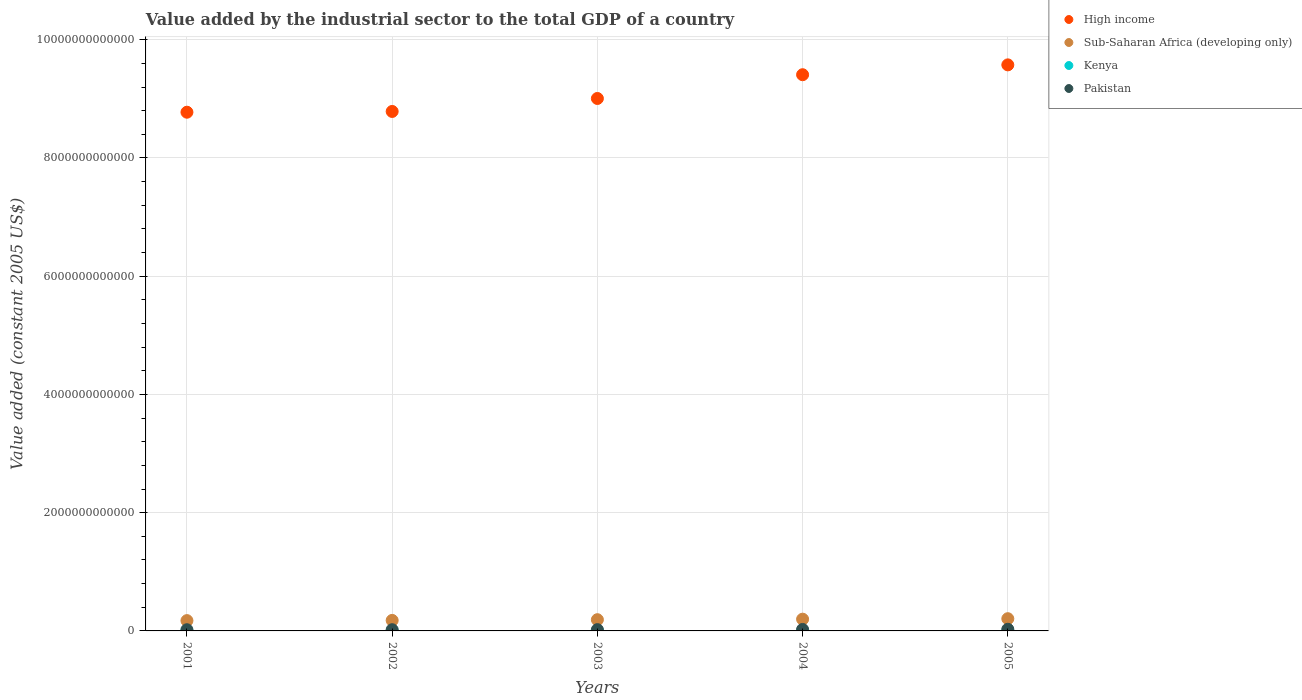How many different coloured dotlines are there?
Keep it short and to the point. 4. Is the number of dotlines equal to the number of legend labels?
Your answer should be very brief. Yes. What is the value added by the industrial sector in Pakistan in 2002?
Provide a succinct answer. 2.06e+1. Across all years, what is the maximum value added by the industrial sector in Kenya?
Offer a very short reply. 3.19e+09. Across all years, what is the minimum value added by the industrial sector in Pakistan?
Give a very brief answer. 2.00e+1. In which year was the value added by the industrial sector in Sub-Saharan Africa (developing only) maximum?
Offer a very short reply. 2005. In which year was the value added by the industrial sector in Kenya minimum?
Give a very brief answer. 2001. What is the total value added by the industrial sector in Sub-Saharan Africa (developing only) in the graph?
Provide a succinct answer. 9.48e+11. What is the difference between the value added by the industrial sector in Sub-Saharan Africa (developing only) in 2001 and that in 2005?
Offer a terse response. -3.26e+1. What is the difference between the value added by the industrial sector in High income in 2001 and the value added by the industrial sector in Pakistan in 2005?
Provide a short and direct response. 8.75e+12. What is the average value added by the industrial sector in High income per year?
Make the answer very short. 9.11e+12. In the year 2004, what is the difference between the value added by the industrial sector in Sub-Saharan Africa (developing only) and value added by the industrial sector in High income?
Provide a succinct answer. -9.21e+12. What is the ratio of the value added by the industrial sector in Kenya in 2002 to that in 2003?
Make the answer very short. 0.94. Is the value added by the industrial sector in High income in 2002 less than that in 2003?
Your answer should be very brief. Yes. Is the difference between the value added by the industrial sector in Sub-Saharan Africa (developing only) in 2002 and 2005 greater than the difference between the value added by the industrial sector in High income in 2002 and 2005?
Keep it short and to the point. Yes. What is the difference between the highest and the second highest value added by the industrial sector in Sub-Saharan Africa (developing only)?
Give a very brief answer. 8.32e+09. What is the difference between the highest and the lowest value added by the industrial sector in Kenya?
Ensure brevity in your answer.  4.86e+08. In how many years, is the value added by the industrial sector in Kenya greater than the average value added by the industrial sector in Kenya taken over all years?
Ensure brevity in your answer.  3. Is it the case that in every year, the sum of the value added by the industrial sector in Sub-Saharan Africa (developing only) and value added by the industrial sector in Pakistan  is greater than the sum of value added by the industrial sector in Kenya and value added by the industrial sector in High income?
Provide a short and direct response. No. Does the value added by the industrial sector in High income monotonically increase over the years?
Provide a succinct answer. Yes. Is the value added by the industrial sector in Pakistan strictly less than the value added by the industrial sector in High income over the years?
Your response must be concise. Yes. How many dotlines are there?
Provide a short and direct response. 4. What is the difference between two consecutive major ticks on the Y-axis?
Keep it short and to the point. 2.00e+12. Are the values on the major ticks of Y-axis written in scientific E-notation?
Your answer should be compact. No. Does the graph contain any zero values?
Keep it short and to the point. No. Does the graph contain grids?
Keep it short and to the point. Yes. Where does the legend appear in the graph?
Your answer should be very brief. Top right. How many legend labels are there?
Ensure brevity in your answer.  4. What is the title of the graph?
Your answer should be compact. Value added by the industrial sector to the total GDP of a country. Does "Macao" appear as one of the legend labels in the graph?
Ensure brevity in your answer.  No. What is the label or title of the X-axis?
Your answer should be very brief. Years. What is the label or title of the Y-axis?
Ensure brevity in your answer.  Value added (constant 2005 US$). What is the Value added (constant 2005 US$) of High income in 2001?
Make the answer very short. 8.77e+12. What is the Value added (constant 2005 US$) of Sub-Saharan Africa (developing only) in 2001?
Your answer should be compact. 1.74e+11. What is the Value added (constant 2005 US$) of Kenya in 2001?
Offer a terse response. 2.70e+09. What is the Value added (constant 2005 US$) in Pakistan in 2001?
Provide a short and direct response. 2.00e+1. What is the Value added (constant 2005 US$) in High income in 2002?
Your answer should be very brief. 8.79e+12. What is the Value added (constant 2005 US$) of Sub-Saharan Africa (developing only) in 2002?
Provide a succinct answer. 1.78e+11. What is the Value added (constant 2005 US$) in Kenya in 2002?
Offer a terse response. 2.77e+09. What is the Value added (constant 2005 US$) in Pakistan in 2002?
Give a very brief answer. 2.06e+1. What is the Value added (constant 2005 US$) of High income in 2003?
Provide a short and direct response. 9.01e+12. What is the Value added (constant 2005 US$) in Sub-Saharan Africa (developing only) in 2003?
Provide a succinct answer. 1.90e+11. What is the Value added (constant 2005 US$) of Kenya in 2003?
Offer a very short reply. 2.93e+09. What is the Value added (constant 2005 US$) of Pakistan in 2003?
Offer a terse response. 2.14e+1. What is the Value added (constant 2005 US$) of High income in 2004?
Offer a terse response. 9.41e+12. What is the Value added (constant 2005 US$) in Sub-Saharan Africa (developing only) in 2004?
Ensure brevity in your answer.  1.99e+11. What is the Value added (constant 2005 US$) in Kenya in 2004?
Offer a terse response. 3.05e+09. What is the Value added (constant 2005 US$) of Pakistan in 2004?
Make the answer very short. 2.49e+1. What is the Value added (constant 2005 US$) of High income in 2005?
Keep it short and to the point. 9.57e+12. What is the Value added (constant 2005 US$) in Sub-Saharan Africa (developing only) in 2005?
Your response must be concise. 2.07e+11. What is the Value added (constant 2005 US$) in Kenya in 2005?
Your answer should be compact. 3.19e+09. What is the Value added (constant 2005 US$) in Pakistan in 2005?
Offer a terse response. 2.80e+1. Across all years, what is the maximum Value added (constant 2005 US$) of High income?
Make the answer very short. 9.57e+12. Across all years, what is the maximum Value added (constant 2005 US$) in Sub-Saharan Africa (developing only)?
Your response must be concise. 2.07e+11. Across all years, what is the maximum Value added (constant 2005 US$) of Kenya?
Make the answer very short. 3.19e+09. Across all years, what is the maximum Value added (constant 2005 US$) in Pakistan?
Offer a terse response. 2.80e+1. Across all years, what is the minimum Value added (constant 2005 US$) in High income?
Your response must be concise. 8.77e+12. Across all years, what is the minimum Value added (constant 2005 US$) in Sub-Saharan Africa (developing only)?
Keep it short and to the point. 1.74e+11. Across all years, what is the minimum Value added (constant 2005 US$) of Kenya?
Provide a short and direct response. 2.70e+09. Across all years, what is the minimum Value added (constant 2005 US$) of Pakistan?
Provide a short and direct response. 2.00e+1. What is the total Value added (constant 2005 US$) in High income in the graph?
Keep it short and to the point. 4.55e+13. What is the total Value added (constant 2005 US$) in Sub-Saharan Africa (developing only) in the graph?
Provide a short and direct response. 9.48e+11. What is the total Value added (constant 2005 US$) in Kenya in the graph?
Ensure brevity in your answer.  1.46e+1. What is the total Value added (constant 2005 US$) of Pakistan in the graph?
Provide a succinct answer. 1.15e+11. What is the difference between the Value added (constant 2005 US$) in High income in 2001 and that in 2002?
Give a very brief answer. -1.29e+1. What is the difference between the Value added (constant 2005 US$) of Sub-Saharan Africa (developing only) in 2001 and that in 2002?
Offer a very short reply. -3.59e+09. What is the difference between the Value added (constant 2005 US$) in Kenya in 2001 and that in 2002?
Keep it short and to the point. -6.34e+07. What is the difference between the Value added (constant 2005 US$) of Pakistan in 2001 and that in 2002?
Make the answer very short. -5.41e+08. What is the difference between the Value added (constant 2005 US$) of High income in 2001 and that in 2003?
Make the answer very short. -2.32e+11. What is the difference between the Value added (constant 2005 US$) of Sub-Saharan Africa (developing only) in 2001 and that in 2003?
Your response must be concise. -1.57e+1. What is the difference between the Value added (constant 2005 US$) in Kenya in 2001 and that in 2003?
Offer a terse response. -2.33e+08. What is the difference between the Value added (constant 2005 US$) in Pakistan in 2001 and that in 2003?
Ensure brevity in your answer.  -1.41e+09. What is the difference between the Value added (constant 2005 US$) in High income in 2001 and that in 2004?
Ensure brevity in your answer.  -6.34e+11. What is the difference between the Value added (constant 2005 US$) of Sub-Saharan Africa (developing only) in 2001 and that in 2004?
Provide a succinct answer. -2.43e+1. What is the difference between the Value added (constant 2005 US$) of Kenya in 2001 and that in 2004?
Provide a short and direct response. -3.52e+08. What is the difference between the Value added (constant 2005 US$) of Pakistan in 2001 and that in 2004?
Keep it short and to the point. -4.90e+09. What is the difference between the Value added (constant 2005 US$) of High income in 2001 and that in 2005?
Keep it short and to the point. -8.01e+11. What is the difference between the Value added (constant 2005 US$) in Sub-Saharan Africa (developing only) in 2001 and that in 2005?
Offer a terse response. -3.26e+1. What is the difference between the Value added (constant 2005 US$) of Kenya in 2001 and that in 2005?
Provide a succinct answer. -4.86e+08. What is the difference between the Value added (constant 2005 US$) of Pakistan in 2001 and that in 2005?
Offer a terse response. -7.92e+09. What is the difference between the Value added (constant 2005 US$) in High income in 2002 and that in 2003?
Provide a short and direct response. -2.19e+11. What is the difference between the Value added (constant 2005 US$) in Sub-Saharan Africa (developing only) in 2002 and that in 2003?
Your response must be concise. -1.21e+1. What is the difference between the Value added (constant 2005 US$) of Kenya in 2002 and that in 2003?
Make the answer very short. -1.69e+08. What is the difference between the Value added (constant 2005 US$) of Pakistan in 2002 and that in 2003?
Provide a short and direct response. -8.72e+08. What is the difference between the Value added (constant 2005 US$) of High income in 2002 and that in 2004?
Keep it short and to the point. -6.21e+11. What is the difference between the Value added (constant 2005 US$) in Sub-Saharan Africa (developing only) in 2002 and that in 2004?
Keep it short and to the point. -2.07e+1. What is the difference between the Value added (constant 2005 US$) of Kenya in 2002 and that in 2004?
Offer a terse response. -2.89e+08. What is the difference between the Value added (constant 2005 US$) of Pakistan in 2002 and that in 2004?
Ensure brevity in your answer.  -4.36e+09. What is the difference between the Value added (constant 2005 US$) in High income in 2002 and that in 2005?
Offer a terse response. -7.88e+11. What is the difference between the Value added (constant 2005 US$) in Sub-Saharan Africa (developing only) in 2002 and that in 2005?
Give a very brief answer. -2.90e+1. What is the difference between the Value added (constant 2005 US$) of Kenya in 2002 and that in 2005?
Offer a terse response. -4.23e+08. What is the difference between the Value added (constant 2005 US$) in Pakistan in 2002 and that in 2005?
Give a very brief answer. -7.38e+09. What is the difference between the Value added (constant 2005 US$) of High income in 2003 and that in 2004?
Offer a terse response. -4.02e+11. What is the difference between the Value added (constant 2005 US$) in Sub-Saharan Africa (developing only) in 2003 and that in 2004?
Provide a succinct answer. -8.58e+09. What is the difference between the Value added (constant 2005 US$) in Kenya in 2003 and that in 2004?
Your answer should be compact. -1.20e+08. What is the difference between the Value added (constant 2005 US$) in Pakistan in 2003 and that in 2004?
Provide a succinct answer. -3.49e+09. What is the difference between the Value added (constant 2005 US$) of High income in 2003 and that in 2005?
Make the answer very short. -5.68e+11. What is the difference between the Value added (constant 2005 US$) in Sub-Saharan Africa (developing only) in 2003 and that in 2005?
Ensure brevity in your answer.  -1.69e+1. What is the difference between the Value added (constant 2005 US$) in Kenya in 2003 and that in 2005?
Your answer should be very brief. -2.54e+08. What is the difference between the Value added (constant 2005 US$) of Pakistan in 2003 and that in 2005?
Ensure brevity in your answer.  -6.51e+09. What is the difference between the Value added (constant 2005 US$) in High income in 2004 and that in 2005?
Your answer should be compact. -1.67e+11. What is the difference between the Value added (constant 2005 US$) in Sub-Saharan Africa (developing only) in 2004 and that in 2005?
Keep it short and to the point. -8.32e+09. What is the difference between the Value added (constant 2005 US$) in Kenya in 2004 and that in 2005?
Offer a terse response. -1.34e+08. What is the difference between the Value added (constant 2005 US$) in Pakistan in 2004 and that in 2005?
Your answer should be very brief. -3.02e+09. What is the difference between the Value added (constant 2005 US$) in High income in 2001 and the Value added (constant 2005 US$) in Sub-Saharan Africa (developing only) in 2002?
Make the answer very short. 8.60e+12. What is the difference between the Value added (constant 2005 US$) in High income in 2001 and the Value added (constant 2005 US$) in Kenya in 2002?
Your answer should be very brief. 8.77e+12. What is the difference between the Value added (constant 2005 US$) in High income in 2001 and the Value added (constant 2005 US$) in Pakistan in 2002?
Offer a terse response. 8.75e+12. What is the difference between the Value added (constant 2005 US$) of Sub-Saharan Africa (developing only) in 2001 and the Value added (constant 2005 US$) of Kenya in 2002?
Give a very brief answer. 1.72e+11. What is the difference between the Value added (constant 2005 US$) of Sub-Saharan Africa (developing only) in 2001 and the Value added (constant 2005 US$) of Pakistan in 2002?
Provide a short and direct response. 1.54e+11. What is the difference between the Value added (constant 2005 US$) of Kenya in 2001 and the Value added (constant 2005 US$) of Pakistan in 2002?
Your answer should be compact. -1.79e+1. What is the difference between the Value added (constant 2005 US$) of High income in 2001 and the Value added (constant 2005 US$) of Sub-Saharan Africa (developing only) in 2003?
Keep it short and to the point. 8.58e+12. What is the difference between the Value added (constant 2005 US$) of High income in 2001 and the Value added (constant 2005 US$) of Kenya in 2003?
Offer a terse response. 8.77e+12. What is the difference between the Value added (constant 2005 US$) of High income in 2001 and the Value added (constant 2005 US$) of Pakistan in 2003?
Ensure brevity in your answer.  8.75e+12. What is the difference between the Value added (constant 2005 US$) of Sub-Saharan Africa (developing only) in 2001 and the Value added (constant 2005 US$) of Kenya in 2003?
Your answer should be compact. 1.71e+11. What is the difference between the Value added (constant 2005 US$) of Sub-Saharan Africa (developing only) in 2001 and the Value added (constant 2005 US$) of Pakistan in 2003?
Your answer should be very brief. 1.53e+11. What is the difference between the Value added (constant 2005 US$) of Kenya in 2001 and the Value added (constant 2005 US$) of Pakistan in 2003?
Offer a very short reply. -1.87e+1. What is the difference between the Value added (constant 2005 US$) in High income in 2001 and the Value added (constant 2005 US$) in Sub-Saharan Africa (developing only) in 2004?
Your response must be concise. 8.58e+12. What is the difference between the Value added (constant 2005 US$) in High income in 2001 and the Value added (constant 2005 US$) in Kenya in 2004?
Keep it short and to the point. 8.77e+12. What is the difference between the Value added (constant 2005 US$) in High income in 2001 and the Value added (constant 2005 US$) in Pakistan in 2004?
Give a very brief answer. 8.75e+12. What is the difference between the Value added (constant 2005 US$) in Sub-Saharan Africa (developing only) in 2001 and the Value added (constant 2005 US$) in Kenya in 2004?
Ensure brevity in your answer.  1.71e+11. What is the difference between the Value added (constant 2005 US$) in Sub-Saharan Africa (developing only) in 2001 and the Value added (constant 2005 US$) in Pakistan in 2004?
Your response must be concise. 1.49e+11. What is the difference between the Value added (constant 2005 US$) of Kenya in 2001 and the Value added (constant 2005 US$) of Pakistan in 2004?
Make the answer very short. -2.22e+1. What is the difference between the Value added (constant 2005 US$) of High income in 2001 and the Value added (constant 2005 US$) of Sub-Saharan Africa (developing only) in 2005?
Your answer should be compact. 8.57e+12. What is the difference between the Value added (constant 2005 US$) of High income in 2001 and the Value added (constant 2005 US$) of Kenya in 2005?
Provide a short and direct response. 8.77e+12. What is the difference between the Value added (constant 2005 US$) in High income in 2001 and the Value added (constant 2005 US$) in Pakistan in 2005?
Your answer should be very brief. 8.75e+12. What is the difference between the Value added (constant 2005 US$) of Sub-Saharan Africa (developing only) in 2001 and the Value added (constant 2005 US$) of Kenya in 2005?
Provide a short and direct response. 1.71e+11. What is the difference between the Value added (constant 2005 US$) in Sub-Saharan Africa (developing only) in 2001 and the Value added (constant 2005 US$) in Pakistan in 2005?
Offer a terse response. 1.46e+11. What is the difference between the Value added (constant 2005 US$) of Kenya in 2001 and the Value added (constant 2005 US$) of Pakistan in 2005?
Your response must be concise. -2.53e+1. What is the difference between the Value added (constant 2005 US$) in High income in 2002 and the Value added (constant 2005 US$) in Sub-Saharan Africa (developing only) in 2003?
Give a very brief answer. 8.60e+12. What is the difference between the Value added (constant 2005 US$) of High income in 2002 and the Value added (constant 2005 US$) of Kenya in 2003?
Provide a short and direct response. 8.78e+12. What is the difference between the Value added (constant 2005 US$) of High income in 2002 and the Value added (constant 2005 US$) of Pakistan in 2003?
Make the answer very short. 8.77e+12. What is the difference between the Value added (constant 2005 US$) of Sub-Saharan Africa (developing only) in 2002 and the Value added (constant 2005 US$) of Kenya in 2003?
Provide a succinct answer. 1.75e+11. What is the difference between the Value added (constant 2005 US$) of Sub-Saharan Africa (developing only) in 2002 and the Value added (constant 2005 US$) of Pakistan in 2003?
Provide a succinct answer. 1.56e+11. What is the difference between the Value added (constant 2005 US$) in Kenya in 2002 and the Value added (constant 2005 US$) in Pakistan in 2003?
Offer a terse response. -1.87e+1. What is the difference between the Value added (constant 2005 US$) in High income in 2002 and the Value added (constant 2005 US$) in Sub-Saharan Africa (developing only) in 2004?
Offer a very short reply. 8.59e+12. What is the difference between the Value added (constant 2005 US$) in High income in 2002 and the Value added (constant 2005 US$) in Kenya in 2004?
Provide a short and direct response. 8.78e+12. What is the difference between the Value added (constant 2005 US$) in High income in 2002 and the Value added (constant 2005 US$) in Pakistan in 2004?
Make the answer very short. 8.76e+12. What is the difference between the Value added (constant 2005 US$) in Sub-Saharan Africa (developing only) in 2002 and the Value added (constant 2005 US$) in Kenya in 2004?
Your answer should be compact. 1.75e+11. What is the difference between the Value added (constant 2005 US$) in Sub-Saharan Africa (developing only) in 2002 and the Value added (constant 2005 US$) in Pakistan in 2004?
Ensure brevity in your answer.  1.53e+11. What is the difference between the Value added (constant 2005 US$) of Kenya in 2002 and the Value added (constant 2005 US$) of Pakistan in 2004?
Make the answer very short. -2.22e+1. What is the difference between the Value added (constant 2005 US$) in High income in 2002 and the Value added (constant 2005 US$) in Sub-Saharan Africa (developing only) in 2005?
Keep it short and to the point. 8.58e+12. What is the difference between the Value added (constant 2005 US$) in High income in 2002 and the Value added (constant 2005 US$) in Kenya in 2005?
Provide a succinct answer. 8.78e+12. What is the difference between the Value added (constant 2005 US$) in High income in 2002 and the Value added (constant 2005 US$) in Pakistan in 2005?
Offer a terse response. 8.76e+12. What is the difference between the Value added (constant 2005 US$) of Sub-Saharan Africa (developing only) in 2002 and the Value added (constant 2005 US$) of Kenya in 2005?
Offer a terse response. 1.75e+11. What is the difference between the Value added (constant 2005 US$) in Sub-Saharan Africa (developing only) in 2002 and the Value added (constant 2005 US$) in Pakistan in 2005?
Keep it short and to the point. 1.50e+11. What is the difference between the Value added (constant 2005 US$) in Kenya in 2002 and the Value added (constant 2005 US$) in Pakistan in 2005?
Provide a succinct answer. -2.52e+1. What is the difference between the Value added (constant 2005 US$) in High income in 2003 and the Value added (constant 2005 US$) in Sub-Saharan Africa (developing only) in 2004?
Your response must be concise. 8.81e+12. What is the difference between the Value added (constant 2005 US$) of High income in 2003 and the Value added (constant 2005 US$) of Kenya in 2004?
Ensure brevity in your answer.  9.00e+12. What is the difference between the Value added (constant 2005 US$) of High income in 2003 and the Value added (constant 2005 US$) of Pakistan in 2004?
Provide a short and direct response. 8.98e+12. What is the difference between the Value added (constant 2005 US$) of Sub-Saharan Africa (developing only) in 2003 and the Value added (constant 2005 US$) of Kenya in 2004?
Make the answer very short. 1.87e+11. What is the difference between the Value added (constant 2005 US$) of Sub-Saharan Africa (developing only) in 2003 and the Value added (constant 2005 US$) of Pakistan in 2004?
Give a very brief answer. 1.65e+11. What is the difference between the Value added (constant 2005 US$) of Kenya in 2003 and the Value added (constant 2005 US$) of Pakistan in 2004?
Make the answer very short. -2.20e+1. What is the difference between the Value added (constant 2005 US$) in High income in 2003 and the Value added (constant 2005 US$) in Sub-Saharan Africa (developing only) in 2005?
Make the answer very short. 8.80e+12. What is the difference between the Value added (constant 2005 US$) in High income in 2003 and the Value added (constant 2005 US$) in Kenya in 2005?
Your answer should be very brief. 9.00e+12. What is the difference between the Value added (constant 2005 US$) in High income in 2003 and the Value added (constant 2005 US$) in Pakistan in 2005?
Your answer should be compact. 8.98e+12. What is the difference between the Value added (constant 2005 US$) of Sub-Saharan Africa (developing only) in 2003 and the Value added (constant 2005 US$) of Kenya in 2005?
Ensure brevity in your answer.  1.87e+11. What is the difference between the Value added (constant 2005 US$) of Sub-Saharan Africa (developing only) in 2003 and the Value added (constant 2005 US$) of Pakistan in 2005?
Give a very brief answer. 1.62e+11. What is the difference between the Value added (constant 2005 US$) of Kenya in 2003 and the Value added (constant 2005 US$) of Pakistan in 2005?
Give a very brief answer. -2.50e+1. What is the difference between the Value added (constant 2005 US$) of High income in 2004 and the Value added (constant 2005 US$) of Sub-Saharan Africa (developing only) in 2005?
Make the answer very short. 9.20e+12. What is the difference between the Value added (constant 2005 US$) in High income in 2004 and the Value added (constant 2005 US$) in Kenya in 2005?
Your answer should be very brief. 9.40e+12. What is the difference between the Value added (constant 2005 US$) in High income in 2004 and the Value added (constant 2005 US$) in Pakistan in 2005?
Offer a terse response. 9.38e+12. What is the difference between the Value added (constant 2005 US$) in Sub-Saharan Africa (developing only) in 2004 and the Value added (constant 2005 US$) in Kenya in 2005?
Your answer should be compact. 1.95e+11. What is the difference between the Value added (constant 2005 US$) in Sub-Saharan Africa (developing only) in 2004 and the Value added (constant 2005 US$) in Pakistan in 2005?
Offer a very short reply. 1.71e+11. What is the difference between the Value added (constant 2005 US$) in Kenya in 2004 and the Value added (constant 2005 US$) in Pakistan in 2005?
Your answer should be compact. -2.49e+1. What is the average Value added (constant 2005 US$) of High income per year?
Give a very brief answer. 9.11e+12. What is the average Value added (constant 2005 US$) in Sub-Saharan Africa (developing only) per year?
Provide a succinct answer. 1.90e+11. What is the average Value added (constant 2005 US$) in Kenya per year?
Offer a very short reply. 2.93e+09. What is the average Value added (constant 2005 US$) in Pakistan per year?
Offer a terse response. 2.30e+1. In the year 2001, what is the difference between the Value added (constant 2005 US$) in High income and Value added (constant 2005 US$) in Sub-Saharan Africa (developing only)?
Provide a short and direct response. 8.60e+12. In the year 2001, what is the difference between the Value added (constant 2005 US$) of High income and Value added (constant 2005 US$) of Kenya?
Keep it short and to the point. 8.77e+12. In the year 2001, what is the difference between the Value added (constant 2005 US$) of High income and Value added (constant 2005 US$) of Pakistan?
Your response must be concise. 8.75e+12. In the year 2001, what is the difference between the Value added (constant 2005 US$) of Sub-Saharan Africa (developing only) and Value added (constant 2005 US$) of Kenya?
Your answer should be compact. 1.72e+11. In the year 2001, what is the difference between the Value added (constant 2005 US$) of Sub-Saharan Africa (developing only) and Value added (constant 2005 US$) of Pakistan?
Make the answer very short. 1.54e+11. In the year 2001, what is the difference between the Value added (constant 2005 US$) in Kenya and Value added (constant 2005 US$) in Pakistan?
Offer a terse response. -1.73e+1. In the year 2002, what is the difference between the Value added (constant 2005 US$) of High income and Value added (constant 2005 US$) of Sub-Saharan Africa (developing only)?
Ensure brevity in your answer.  8.61e+12. In the year 2002, what is the difference between the Value added (constant 2005 US$) of High income and Value added (constant 2005 US$) of Kenya?
Give a very brief answer. 8.78e+12. In the year 2002, what is the difference between the Value added (constant 2005 US$) in High income and Value added (constant 2005 US$) in Pakistan?
Make the answer very short. 8.77e+12. In the year 2002, what is the difference between the Value added (constant 2005 US$) of Sub-Saharan Africa (developing only) and Value added (constant 2005 US$) of Kenya?
Your answer should be compact. 1.75e+11. In the year 2002, what is the difference between the Value added (constant 2005 US$) in Sub-Saharan Africa (developing only) and Value added (constant 2005 US$) in Pakistan?
Your response must be concise. 1.57e+11. In the year 2002, what is the difference between the Value added (constant 2005 US$) in Kenya and Value added (constant 2005 US$) in Pakistan?
Your answer should be compact. -1.78e+1. In the year 2003, what is the difference between the Value added (constant 2005 US$) in High income and Value added (constant 2005 US$) in Sub-Saharan Africa (developing only)?
Your answer should be very brief. 8.82e+12. In the year 2003, what is the difference between the Value added (constant 2005 US$) of High income and Value added (constant 2005 US$) of Kenya?
Offer a very short reply. 9.00e+12. In the year 2003, what is the difference between the Value added (constant 2005 US$) in High income and Value added (constant 2005 US$) in Pakistan?
Offer a very short reply. 8.98e+12. In the year 2003, what is the difference between the Value added (constant 2005 US$) in Sub-Saharan Africa (developing only) and Value added (constant 2005 US$) in Kenya?
Offer a terse response. 1.87e+11. In the year 2003, what is the difference between the Value added (constant 2005 US$) of Sub-Saharan Africa (developing only) and Value added (constant 2005 US$) of Pakistan?
Offer a terse response. 1.69e+11. In the year 2003, what is the difference between the Value added (constant 2005 US$) of Kenya and Value added (constant 2005 US$) of Pakistan?
Offer a very short reply. -1.85e+1. In the year 2004, what is the difference between the Value added (constant 2005 US$) in High income and Value added (constant 2005 US$) in Sub-Saharan Africa (developing only)?
Your response must be concise. 9.21e+12. In the year 2004, what is the difference between the Value added (constant 2005 US$) in High income and Value added (constant 2005 US$) in Kenya?
Provide a short and direct response. 9.40e+12. In the year 2004, what is the difference between the Value added (constant 2005 US$) of High income and Value added (constant 2005 US$) of Pakistan?
Offer a terse response. 9.38e+12. In the year 2004, what is the difference between the Value added (constant 2005 US$) of Sub-Saharan Africa (developing only) and Value added (constant 2005 US$) of Kenya?
Ensure brevity in your answer.  1.95e+11. In the year 2004, what is the difference between the Value added (constant 2005 US$) in Sub-Saharan Africa (developing only) and Value added (constant 2005 US$) in Pakistan?
Your response must be concise. 1.74e+11. In the year 2004, what is the difference between the Value added (constant 2005 US$) of Kenya and Value added (constant 2005 US$) of Pakistan?
Your answer should be very brief. -2.19e+1. In the year 2005, what is the difference between the Value added (constant 2005 US$) in High income and Value added (constant 2005 US$) in Sub-Saharan Africa (developing only)?
Give a very brief answer. 9.37e+12. In the year 2005, what is the difference between the Value added (constant 2005 US$) in High income and Value added (constant 2005 US$) in Kenya?
Offer a very short reply. 9.57e+12. In the year 2005, what is the difference between the Value added (constant 2005 US$) in High income and Value added (constant 2005 US$) in Pakistan?
Provide a short and direct response. 9.55e+12. In the year 2005, what is the difference between the Value added (constant 2005 US$) in Sub-Saharan Africa (developing only) and Value added (constant 2005 US$) in Kenya?
Offer a very short reply. 2.04e+11. In the year 2005, what is the difference between the Value added (constant 2005 US$) of Sub-Saharan Africa (developing only) and Value added (constant 2005 US$) of Pakistan?
Your answer should be compact. 1.79e+11. In the year 2005, what is the difference between the Value added (constant 2005 US$) of Kenya and Value added (constant 2005 US$) of Pakistan?
Make the answer very short. -2.48e+1. What is the ratio of the Value added (constant 2005 US$) in High income in 2001 to that in 2002?
Your answer should be very brief. 1. What is the ratio of the Value added (constant 2005 US$) of Sub-Saharan Africa (developing only) in 2001 to that in 2002?
Offer a terse response. 0.98. What is the ratio of the Value added (constant 2005 US$) of Kenya in 2001 to that in 2002?
Keep it short and to the point. 0.98. What is the ratio of the Value added (constant 2005 US$) in Pakistan in 2001 to that in 2002?
Your answer should be very brief. 0.97. What is the ratio of the Value added (constant 2005 US$) of High income in 2001 to that in 2003?
Your response must be concise. 0.97. What is the ratio of the Value added (constant 2005 US$) in Sub-Saharan Africa (developing only) in 2001 to that in 2003?
Keep it short and to the point. 0.92. What is the ratio of the Value added (constant 2005 US$) of Kenya in 2001 to that in 2003?
Keep it short and to the point. 0.92. What is the ratio of the Value added (constant 2005 US$) in Pakistan in 2001 to that in 2003?
Give a very brief answer. 0.93. What is the ratio of the Value added (constant 2005 US$) of High income in 2001 to that in 2004?
Your answer should be very brief. 0.93. What is the ratio of the Value added (constant 2005 US$) in Sub-Saharan Africa (developing only) in 2001 to that in 2004?
Make the answer very short. 0.88. What is the ratio of the Value added (constant 2005 US$) of Kenya in 2001 to that in 2004?
Keep it short and to the point. 0.88. What is the ratio of the Value added (constant 2005 US$) of Pakistan in 2001 to that in 2004?
Ensure brevity in your answer.  0.8. What is the ratio of the Value added (constant 2005 US$) in High income in 2001 to that in 2005?
Make the answer very short. 0.92. What is the ratio of the Value added (constant 2005 US$) in Sub-Saharan Africa (developing only) in 2001 to that in 2005?
Offer a terse response. 0.84. What is the ratio of the Value added (constant 2005 US$) of Kenya in 2001 to that in 2005?
Give a very brief answer. 0.85. What is the ratio of the Value added (constant 2005 US$) in Pakistan in 2001 to that in 2005?
Your answer should be very brief. 0.72. What is the ratio of the Value added (constant 2005 US$) in High income in 2002 to that in 2003?
Offer a very short reply. 0.98. What is the ratio of the Value added (constant 2005 US$) in Sub-Saharan Africa (developing only) in 2002 to that in 2003?
Offer a very short reply. 0.94. What is the ratio of the Value added (constant 2005 US$) of Kenya in 2002 to that in 2003?
Keep it short and to the point. 0.94. What is the ratio of the Value added (constant 2005 US$) of Pakistan in 2002 to that in 2003?
Your answer should be compact. 0.96. What is the ratio of the Value added (constant 2005 US$) in High income in 2002 to that in 2004?
Keep it short and to the point. 0.93. What is the ratio of the Value added (constant 2005 US$) in Sub-Saharan Africa (developing only) in 2002 to that in 2004?
Offer a very short reply. 0.9. What is the ratio of the Value added (constant 2005 US$) in Kenya in 2002 to that in 2004?
Make the answer very short. 0.91. What is the ratio of the Value added (constant 2005 US$) in Pakistan in 2002 to that in 2004?
Your answer should be very brief. 0.83. What is the ratio of the Value added (constant 2005 US$) in High income in 2002 to that in 2005?
Provide a short and direct response. 0.92. What is the ratio of the Value added (constant 2005 US$) of Sub-Saharan Africa (developing only) in 2002 to that in 2005?
Keep it short and to the point. 0.86. What is the ratio of the Value added (constant 2005 US$) in Kenya in 2002 to that in 2005?
Make the answer very short. 0.87. What is the ratio of the Value added (constant 2005 US$) in Pakistan in 2002 to that in 2005?
Ensure brevity in your answer.  0.74. What is the ratio of the Value added (constant 2005 US$) in High income in 2003 to that in 2004?
Provide a short and direct response. 0.96. What is the ratio of the Value added (constant 2005 US$) of Sub-Saharan Africa (developing only) in 2003 to that in 2004?
Ensure brevity in your answer.  0.96. What is the ratio of the Value added (constant 2005 US$) of Kenya in 2003 to that in 2004?
Ensure brevity in your answer.  0.96. What is the ratio of the Value added (constant 2005 US$) in Pakistan in 2003 to that in 2004?
Make the answer very short. 0.86. What is the ratio of the Value added (constant 2005 US$) of High income in 2003 to that in 2005?
Keep it short and to the point. 0.94. What is the ratio of the Value added (constant 2005 US$) of Sub-Saharan Africa (developing only) in 2003 to that in 2005?
Make the answer very short. 0.92. What is the ratio of the Value added (constant 2005 US$) of Kenya in 2003 to that in 2005?
Give a very brief answer. 0.92. What is the ratio of the Value added (constant 2005 US$) in Pakistan in 2003 to that in 2005?
Your answer should be very brief. 0.77. What is the ratio of the Value added (constant 2005 US$) of High income in 2004 to that in 2005?
Offer a very short reply. 0.98. What is the ratio of the Value added (constant 2005 US$) of Sub-Saharan Africa (developing only) in 2004 to that in 2005?
Provide a succinct answer. 0.96. What is the ratio of the Value added (constant 2005 US$) of Kenya in 2004 to that in 2005?
Offer a terse response. 0.96. What is the ratio of the Value added (constant 2005 US$) in Pakistan in 2004 to that in 2005?
Provide a short and direct response. 0.89. What is the difference between the highest and the second highest Value added (constant 2005 US$) in High income?
Your answer should be very brief. 1.67e+11. What is the difference between the highest and the second highest Value added (constant 2005 US$) in Sub-Saharan Africa (developing only)?
Provide a succinct answer. 8.32e+09. What is the difference between the highest and the second highest Value added (constant 2005 US$) in Kenya?
Ensure brevity in your answer.  1.34e+08. What is the difference between the highest and the second highest Value added (constant 2005 US$) of Pakistan?
Your answer should be compact. 3.02e+09. What is the difference between the highest and the lowest Value added (constant 2005 US$) of High income?
Give a very brief answer. 8.01e+11. What is the difference between the highest and the lowest Value added (constant 2005 US$) of Sub-Saharan Africa (developing only)?
Make the answer very short. 3.26e+1. What is the difference between the highest and the lowest Value added (constant 2005 US$) of Kenya?
Make the answer very short. 4.86e+08. What is the difference between the highest and the lowest Value added (constant 2005 US$) of Pakistan?
Provide a short and direct response. 7.92e+09. 